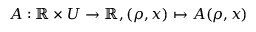<formula> <loc_0><loc_0><loc_500><loc_500>A \colon \mathbb { R } \times U \rightarrow \mathbb { R } , ( \rho , x ) \mapsto A ( \rho , x )</formula> 